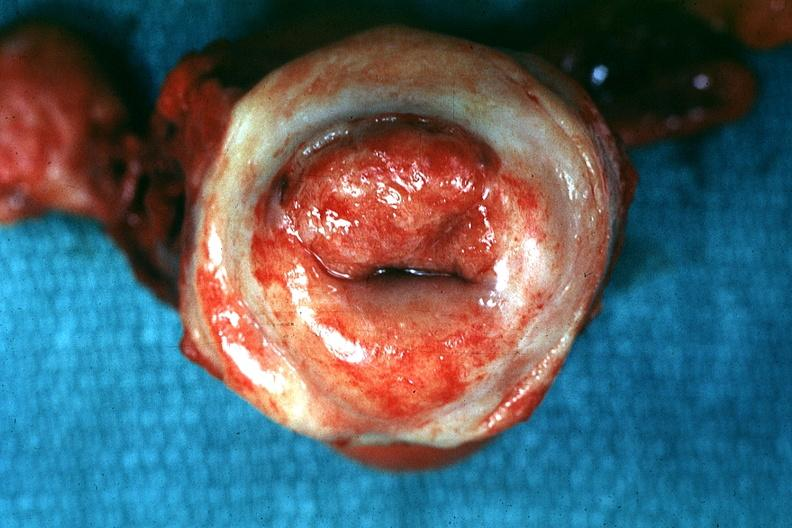s female reproductive present?
Answer the question using a single word or phrase. Yes 